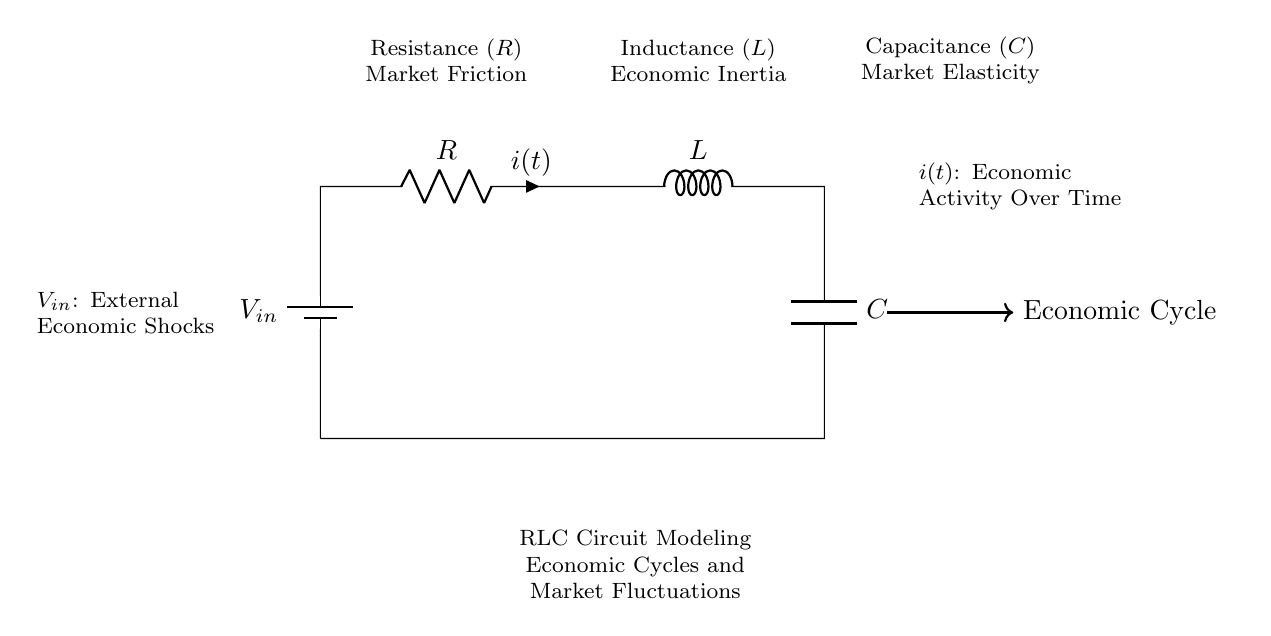What is the type of circuit shown? The circuit consists of a resistor, inductor, and capacitor, which together form what is known as an RLC circuit.
Answer: RLC circuit What does the letter "R" represent in the circuit? "R" indicates resistance, which in this context symbolizes market friction impacting economic cycles.
Answer: Resistance What role does "L" play in the circuit? "L" signifies inductance, representing economic inertia, which denotes how changes in the economic system take time to materialize, similar to current in an inductor.
Answer: Economic inertia What external factor is represented by $V_{in}$? The term $V_{in}$ stands for external economic shocks that influence the circuit and are akin to stimuli affecting market dynamics.
Answer: External economic shocks How does the circuit represent market elasticity? Market elasticity is represented by "C," which indicates capacitance, signifying how responsive the market is to changes over time, similar to how a capacitor stores and releases energy.
Answer: Market elasticity How does current $i(t)$ relate to the economic cycle? The variable $i(t)$ is the current flowing in the circuit, analogous to economic activity over time, reflecting fluctuations in economic cycles based on circuit properties.
Answer: Economic activity over time What component represents market friction? The resistor "R" in the circuit is indicative of market friction, which impedes fluid economic interactions and can slow down the flow of economic activity.
Answer: Resistor 